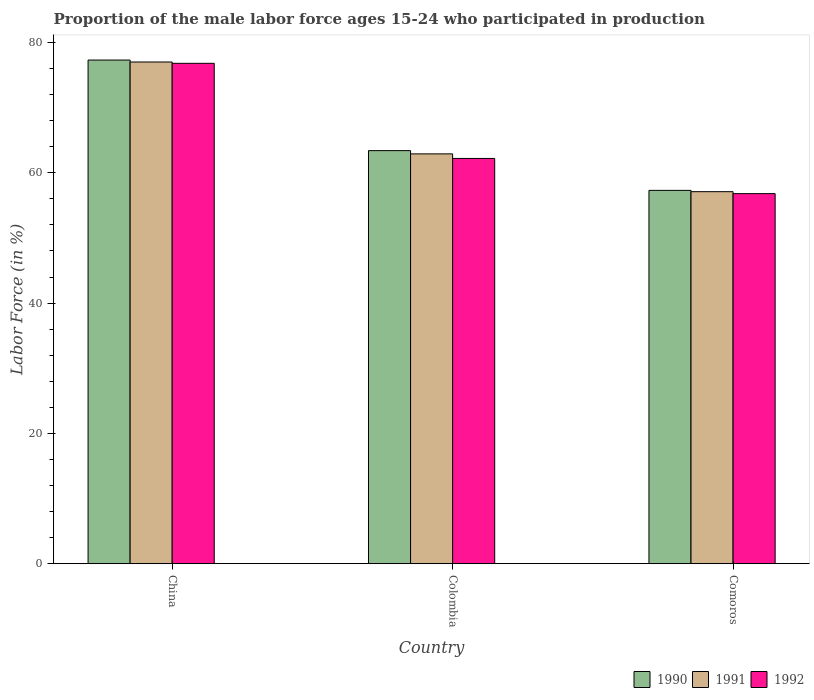How many groups of bars are there?
Ensure brevity in your answer.  3. Are the number of bars per tick equal to the number of legend labels?
Make the answer very short. Yes. How many bars are there on the 2nd tick from the right?
Offer a very short reply. 3. What is the label of the 3rd group of bars from the left?
Offer a terse response. Comoros. In how many cases, is the number of bars for a given country not equal to the number of legend labels?
Provide a short and direct response. 0. What is the proportion of the male labor force who participated in production in 1990 in China?
Make the answer very short. 77.3. Across all countries, what is the maximum proportion of the male labor force who participated in production in 1992?
Offer a terse response. 76.8. Across all countries, what is the minimum proportion of the male labor force who participated in production in 1992?
Offer a terse response. 56.8. In which country was the proportion of the male labor force who participated in production in 1990 maximum?
Your answer should be compact. China. In which country was the proportion of the male labor force who participated in production in 1992 minimum?
Make the answer very short. Comoros. What is the total proportion of the male labor force who participated in production in 1990 in the graph?
Ensure brevity in your answer.  198. What is the difference between the proportion of the male labor force who participated in production in 1990 in Colombia and that in Comoros?
Ensure brevity in your answer.  6.1. What is the difference between the proportion of the male labor force who participated in production in 1990 in Comoros and the proportion of the male labor force who participated in production in 1991 in China?
Provide a succinct answer. -19.7. What is the average proportion of the male labor force who participated in production in 1991 per country?
Your answer should be very brief. 65.67. What is the difference between the proportion of the male labor force who participated in production of/in 1991 and proportion of the male labor force who participated in production of/in 1992 in China?
Provide a succinct answer. 0.2. What is the ratio of the proportion of the male labor force who participated in production in 1991 in Colombia to that in Comoros?
Your response must be concise. 1.1. Is the proportion of the male labor force who participated in production in 1991 in Colombia less than that in Comoros?
Your answer should be very brief. No. Is the difference between the proportion of the male labor force who participated in production in 1991 in China and Colombia greater than the difference between the proportion of the male labor force who participated in production in 1992 in China and Colombia?
Make the answer very short. No. What is the difference between the highest and the second highest proportion of the male labor force who participated in production in 1991?
Give a very brief answer. -19.9. What is the difference between the highest and the lowest proportion of the male labor force who participated in production in 1990?
Make the answer very short. 20. In how many countries, is the proportion of the male labor force who participated in production in 1991 greater than the average proportion of the male labor force who participated in production in 1991 taken over all countries?
Keep it short and to the point. 1. What does the 2nd bar from the left in China represents?
Provide a succinct answer. 1991. What does the 1st bar from the right in Comoros represents?
Provide a succinct answer. 1992. Is it the case that in every country, the sum of the proportion of the male labor force who participated in production in 1991 and proportion of the male labor force who participated in production in 1990 is greater than the proportion of the male labor force who participated in production in 1992?
Make the answer very short. Yes. How many bars are there?
Offer a very short reply. 9. Are all the bars in the graph horizontal?
Keep it short and to the point. No. How many countries are there in the graph?
Offer a terse response. 3. What is the difference between two consecutive major ticks on the Y-axis?
Make the answer very short. 20. Does the graph contain any zero values?
Make the answer very short. No. What is the title of the graph?
Make the answer very short. Proportion of the male labor force ages 15-24 who participated in production. Does "1961" appear as one of the legend labels in the graph?
Offer a very short reply. No. What is the label or title of the Y-axis?
Provide a short and direct response. Labor Force (in %). What is the Labor Force (in %) of 1990 in China?
Your answer should be very brief. 77.3. What is the Labor Force (in %) of 1992 in China?
Offer a very short reply. 76.8. What is the Labor Force (in %) of 1990 in Colombia?
Offer a very short reply. 63.4. What is the Labor Force (in %) of 1991 in Colombia?
Your response must be concise. 62.9. What is the Labor Force (in %) of 1992 in Colombia?
Your answer should be very brief. 62.2. What is the Labor Force (in %) in 1990 in Comoros?
Provide a short and direct response. 57.3. What is the Labor Force (in %) of 1991 in Comoros?
Provide a short and direct response. 57.1. What is the Labor Force (in %) of 1992 in Comoros?
Your answer should be very brief. 56.8. Across all countries, what is the maximum Labor Force (in %) in 1990?
Keep it short and to the point. 77.3. Across all countries, what is the maximum Labor Force (in %) in 1992?
Provide a short and direct response. 76.8. Across all countries, what is the minimum Labor Force (in %) in 1990?
Ensure brevity in your answer.  57.3. Across all countries, what is the minimum Labor Force (in %) in 1991?
Your answer should be very brief. 57.1. Across all countries, what is the minimum Labor Force (in %) of 1992?
Make the answer very short. 56.8. What is the total Labor Force (in %) in 1990 in the graph?
Give a very brief answer. 198. What is the total Labor Force (in %) in 1991 in the graph?
Your response must be concise. 197. What is the total Labor Force (in %) in 1992 in the graph?
Keep it short and to the point. 195.8. What is the difference between the Labor Force (in %) in 1990 in China and that in Colombia?
Ensure brevity in your answer.  13.9. What is the difference between the Labor Force (in %) in 1990 in China and that in Comoros?
Your answer should be compact. 20. What is the difference between the Labor Force (in %) in 1992 in China and that in Comoros?
Your answer should be very brief. 20. What is the difference between the Labor Force (in %) in 1990 in China and the Labor Force (in %) in 1991 in Colombia?
Ensure brevity in your answer.  14.4. What is the difference between the Labor Force (in %) in 1990 in China and the Labor Force (in %) in 1992 in Colombia?
Your answer should be very brief. 15.1. What is the difference between the Labor Force (in %) of 1990 in China and the Labor Force (in %) of 1991 in Comoros?
Ensure brevity in your answer.  20.2. What is the difference between the Labor Force (in %) of 1991 in China and the Labor Force (in %) of 1992 in Comoros?
Your answer should be very brief. 20.2. What is the difference between the Labor Force (in %) in 1990 in Colombia and the Labor Force (in %) in 1992 in Comoros?
Your response must be concise. 6.6. What is the difference between the Labor Force (in %) of 1991 in Colombia and the Labor Force (in %) of 1992 in Comoros?
Your answer should be very brief. 6.1. What is the average Labor Force (in %) in 1990 per country?
Ensure brevity in your answer.  66. What is the average Labor Force (in %) of 1991 per country?
Provide a succinct answer. 65.67. What is the average Labor Force (in %) of 1992 per country?
Your response must be concise. 65.27. What is the difference between the Labor Force (in %) in 1991 and Labor Force (in %) in 1992 in China?
Give a very brief answer. 0.2. What is the difference between the Labor Force (in %) of 1990 and Labor Force (in %) of 1991 in Colombia?
Provide a short and direct response. 0.5. What is the difference between the Labor Force (in %) of 1990 and Labor Force (in %) of 1992 in Colombia?
Your response must be concise. 1.2. What is the difference between the Labor Force (in %) of 1991 and Labor Force (in %) of 1992 in Colombia?
Offer a terse response. 0.7. What is the difference between the Labor Force (in %) in 1990 and Labor Force (in %) in 1992 in Comoros?
Give a very brief answer. 0.5. What is the ratio of the Labor Force (in %) in 1990 in China to that in Colombia?
Provide a succinct answer. 1.22. What is the ratio of the Labor Force (in %) in 1991 in China to that in Colombia?
Offer a terse response. 1.22. What is the ratio of the Labor Force (in %) in 1992 in China to that in Colombia?
Provide a short and direct response. 1.23. What is the ratio of the Labor Force (in %) in 1990 in China to that in Comoros?
Your answer should be compact. 1.35. What is the ratio of the Labor Force (in %) of 1991 in China to that in Comoros?
Your answer should be very brief. 1.35. What is the ratio of the Labor Force (in %) of 1992 in China to that in Comoros?
Provide a succinct answer. 1.35. What is the ratio of the Labor Force (in %) in 1990 in Colombia to that in Comoros?
Your answer should be compact. 1.11. What is the ratio of the Labor Force (in %) of 1991 in Colombia to that in Comoros?
Your response must be concise. 1.1. What is the ratio of the Labor Force (in %) of 1992 in Colombia to that in Comoros?
Give a very brief answer. 1.1. 